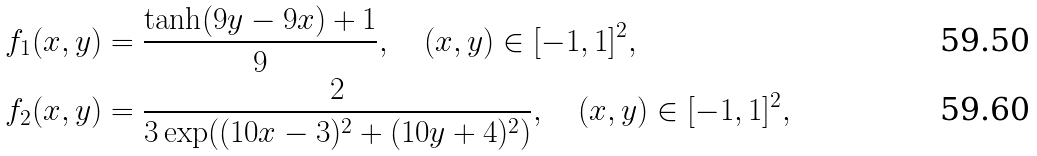<formula> <loc_0><loc_0><loc_500><loc_500>& f _ { 1 } ( x , y ) = \frac { \tanh ( 9 y - 9 x ) + 1 } { 9 } , \quad ( x , y ) \in [ - 1 , 1 ] ^ { 2 } , \\ & f _ { 2 } ( x , y ) = \frac { 2 } { 3 \exp ( ( 1 0 x - 3 ) ^ { 2 } + ( 1 0 y + 4 ) ^ { 2 } ) } , \quad ( x , y ) \in [ - 1 , 1 ] ^ { 2 } ,</formula> 